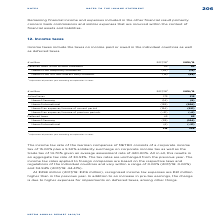According to Metro Ag's financial document, What do income taxes include? the taxes on income paid or owed in the individual countries as well as deferred taxes. The document states: "Income taxes include the taxes on income paid or owed in the individual countries as well as deferred taxes...." Also, What are the recognised income tax expenses in 2019? According to the financial document, €298 million. The relevant text states: "At €298 million (2017/18: €216 million), recognised income tax expenses are €81 million..." Also, What are the components under deferred taxes? The document shows two values: thereof Germany and thereof international. From the document: "thereof international (159) (206) thereof Germany (14) (9)..." Additionally, In which year were the recognised income tax expenses larger? Based on the financial document, the answer is 2018/2019. Also, can you calculate: What was the change in recognised income tax expenses in 2018/2019 from 2017/2018? Based on the calculation: 298-216, the result is 82 (in millions). This is based on the information: "216 298 216 298..." The key data points involved are: 216, 298. Also, can you calculate: What was the percentage change in recognised income tax expenses in 2018/2019 from 2017/2018? To answer this question, I need to perform calculations using the financial data. The calculation is: (298-216)/216, which equals 37.96 (percentage). This is based on the information: "216 298 216 298..." The key data points involved are: 216, 298. 